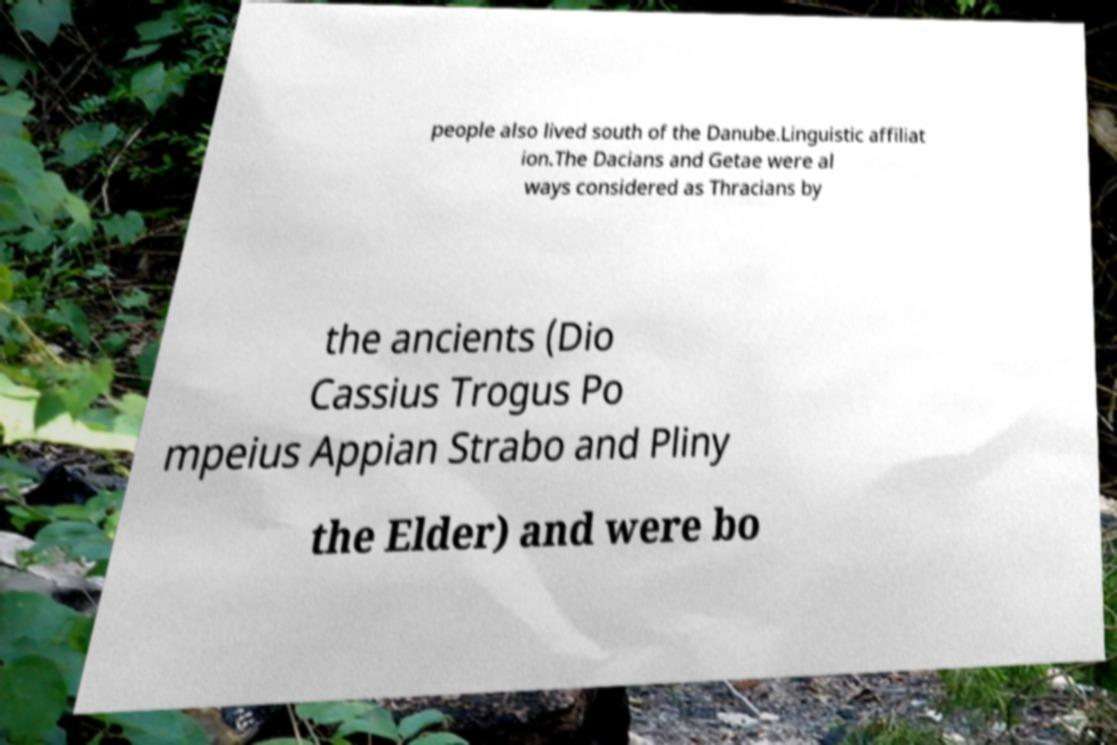There's text embedded in this image that I need extracted. Can you transcribe it verbatim? people also lived south of the Danube.Linguistic affiliat ion.The Dacians and Getae were al ways considered as Thracians by the ancients (Dio Cassius Trogus Po mpeius Appian Strabo and Pliny the Elder) and were bo 